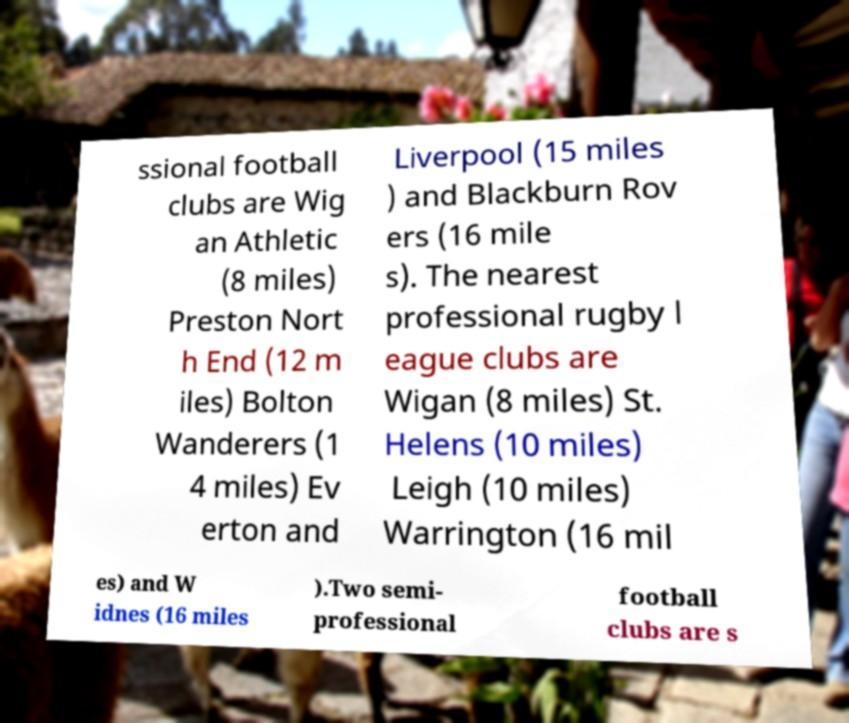Could you assist in decoding the text presented in this image and type it out clearly? ssional football clubs are Wig an Athletic (8 miles) Preston Nort h End (12 m iles) Bolton Wanderers (1 4 miles) Ev erton and Liverpool (15 miles ) and Blackburn Rov ers (16 mile s). The nearest professional rugby l eague clubs are Wigan (8 miles) St. Helens (10 miles) Leigh (10 miles) Warrington (16 mil es) and W idnes (16 miles ).Two semi- professional football clubs are s 